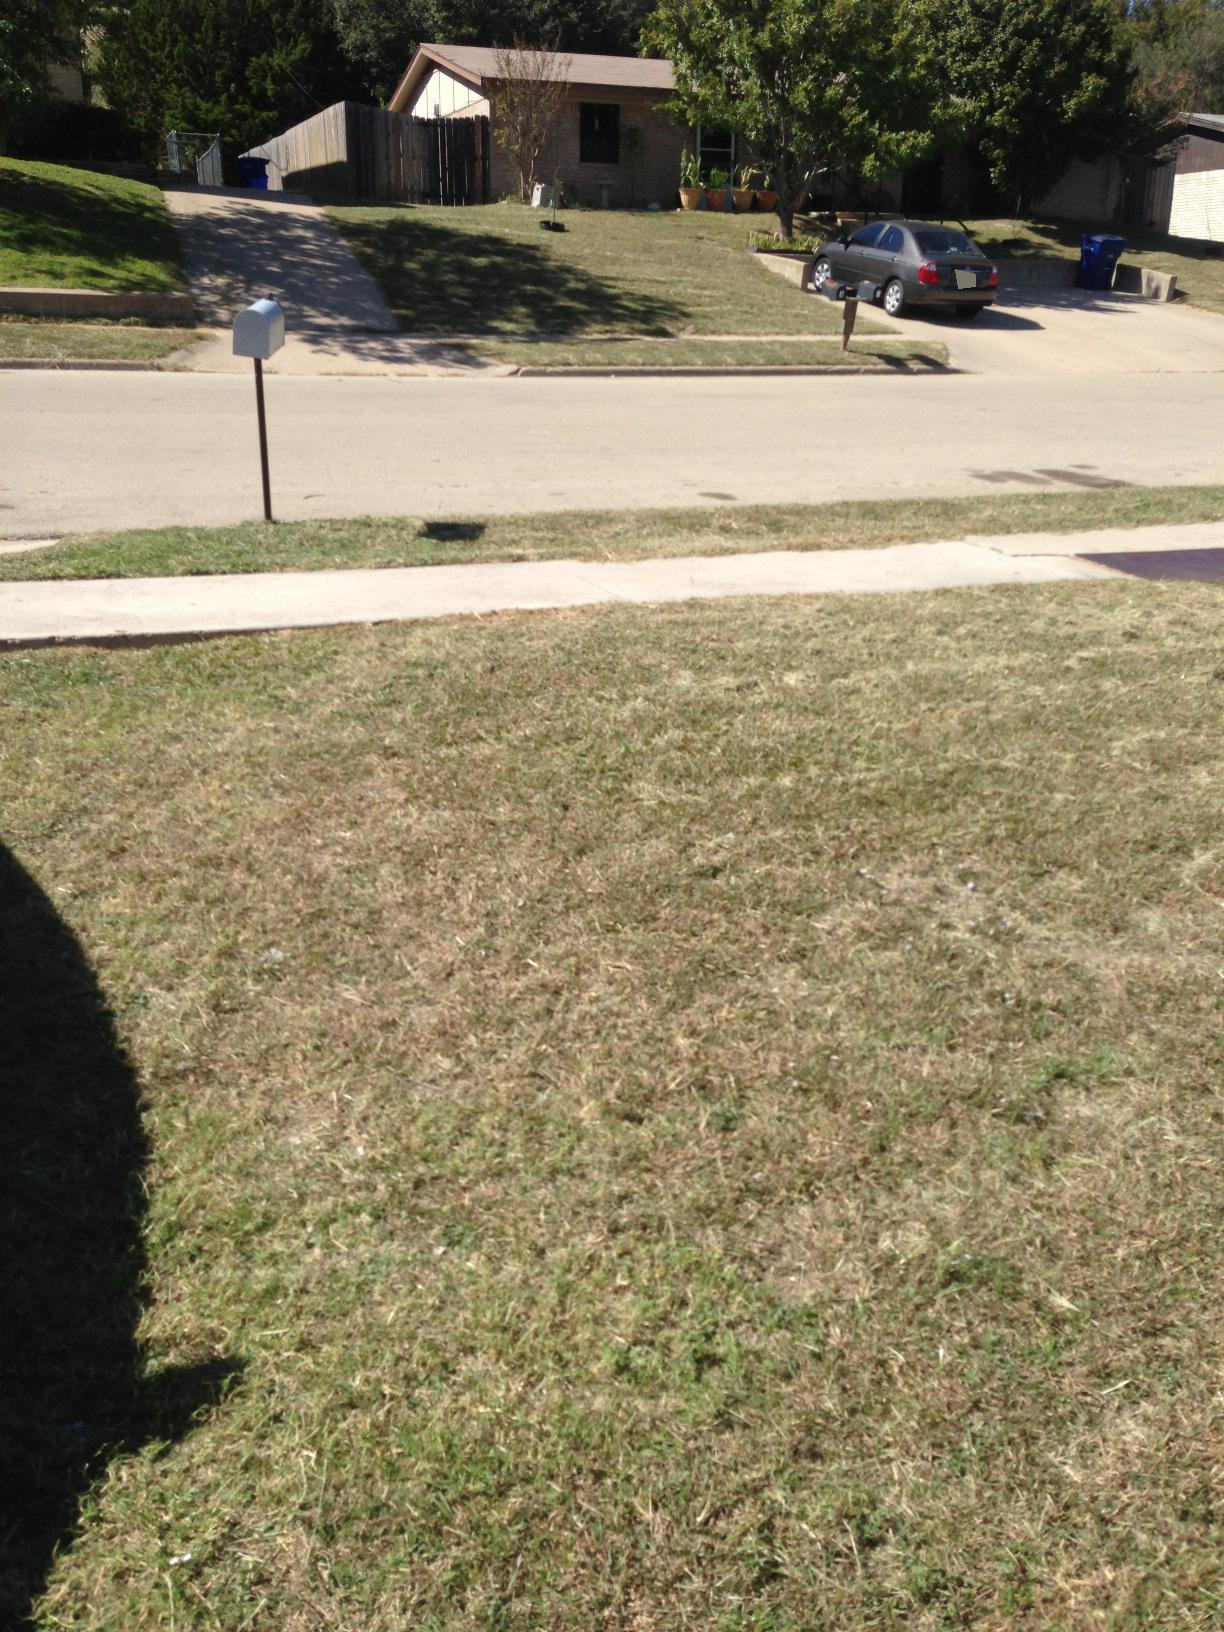What's in this photo? The photo shows a suburban street view. In the foreground, there is a grassy lawn. In the middle ground, there is a white mailbox on the left side and a street running horizontally across the image. Across the street, there is a house with a brown roof and two potted plants on the lawn. A car is parked in the driveway of one of the houses. The scene also features a few trees and a wooden fence. 